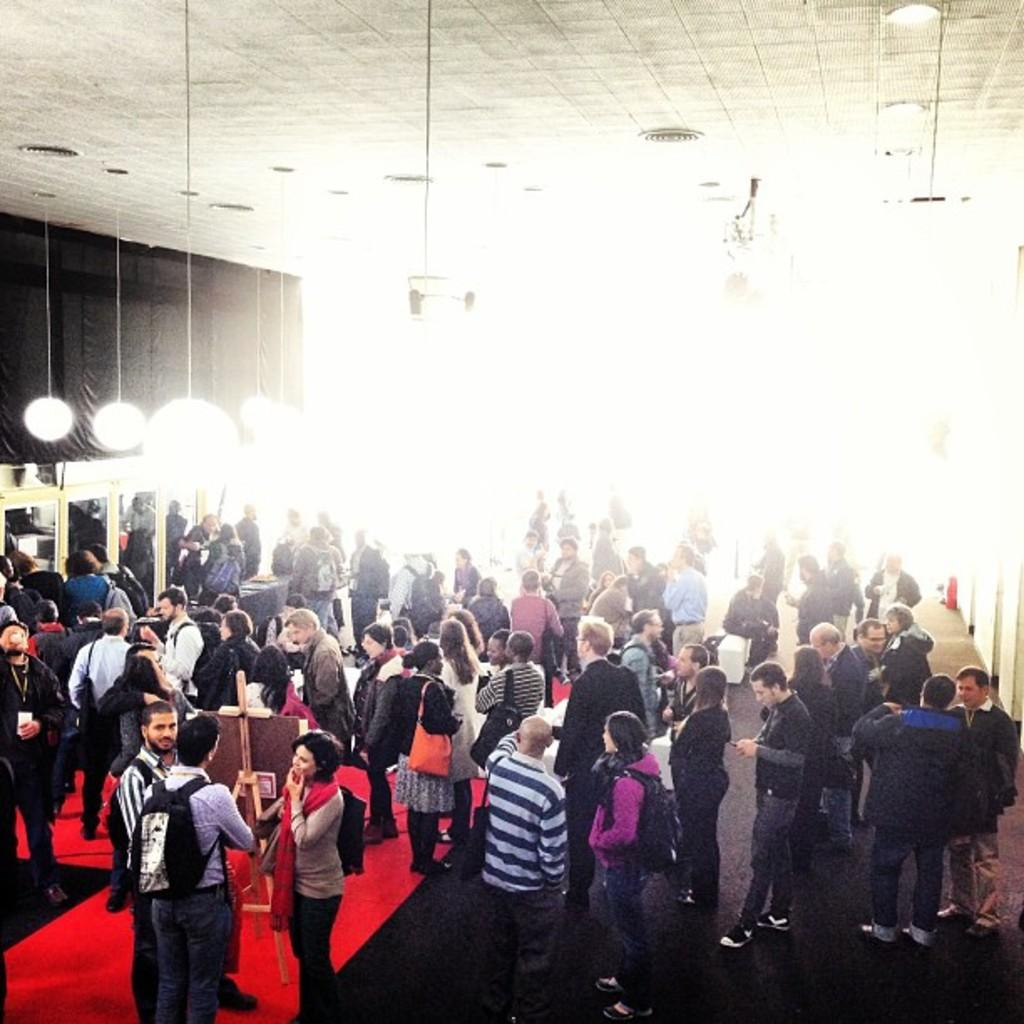How many people are in the image? There is a group of people in the image. What are the people doing in the image? The people are standing on the floor. What are some of the people holding in the image? Some of the people are carrying bags. What can be seen on the ceiling in the background of the image? There are lights on the ceiling in the background of the image. What can be seen on the wall in the background of the image? There are lights on the wall in the background of the image. What other objects can be seen in the background of the image? There are other objects visible in the background of the image. What time does the clock on the wall show in the image? There is no clock visible in the image. Can you describe the stranger standing next to the group of people in the image? There is no stranger present in the image; the group of people consists only of those mentioned in the facts. 